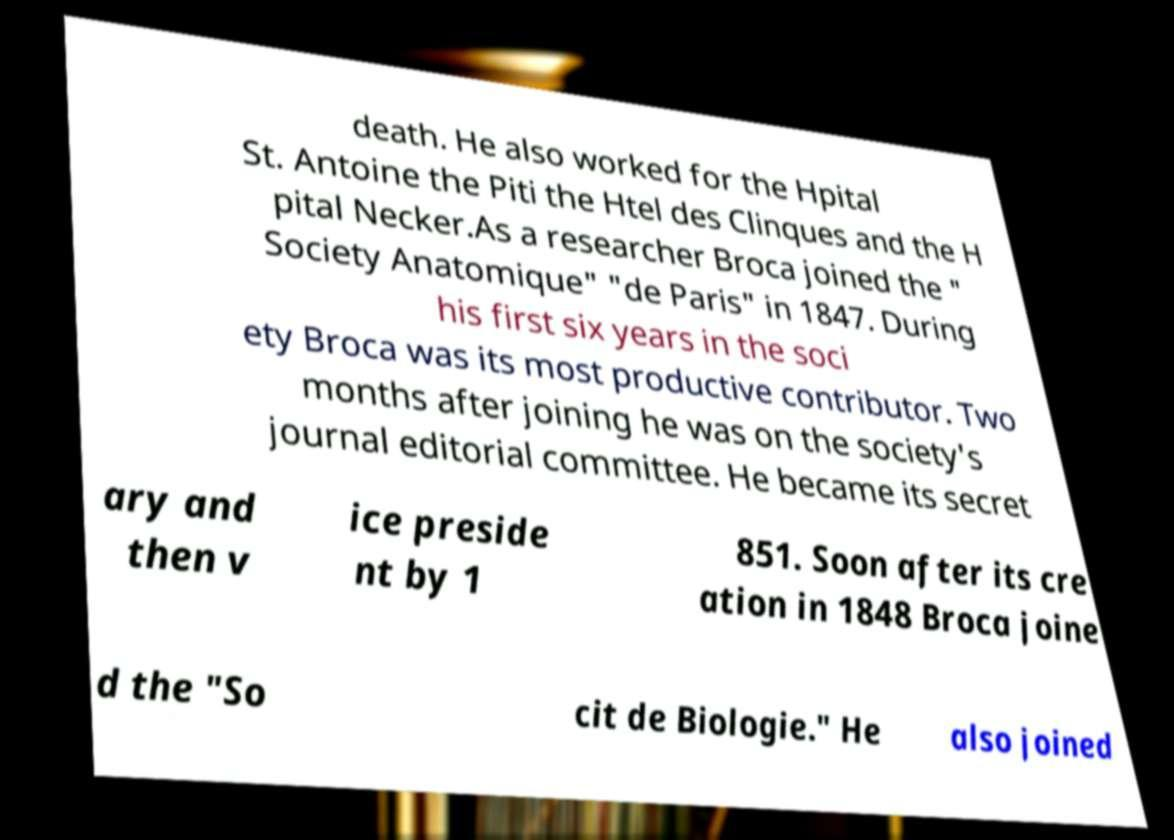What messages or text are displayed in this image? I need them in a readable, typed format. death. He also worked for the Hpital St. Antoine the Piti the Htel des Clinques and the H pital Necker.As a researcher Broca joined the " Society Anatomique" "de Paris" in 1847. During his first six years in the soci ety Broca was its most productive contributor. Two months after joining he was on the society's journal editorial committee. He became its secret ary and then v ice preside nt by 1 851. Soon after its cre ation in 1848 Broca joine d the "So cit de Biologie." He also joined 